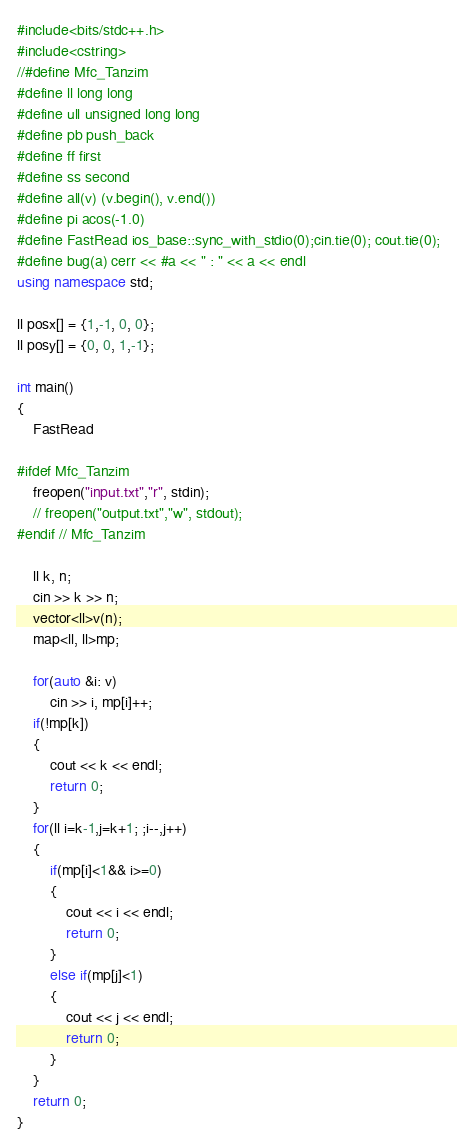<code> <loc_0><loc_0><loc_500><loc_500><_C++_>#include<bits/stdc++.h>
#include<cstring>
//#define Mfc_Tanzim
#define ll long long
#define ull unsigned long long
#define pb push_back
#define ff first
#define ss second
#define all(v) (v.begin(), v.end())
#define pi acos(-1.0)
#define FastRead ios_base::sync_with_stdio(0);cin.tie(0); cout.tie(0);
#define bug(a) cerr << #a << " : " << a << endl
using namespace std;

ll posx[] = {1,-1, 0, 0};
ll posy[] = {0, 0, 1,-1};

int main()
{
    FastRead

#ifdef Mfc_Tanzim
    freopen("input.txt","r", stdin);
    // freopen("output.txt","w", stdout);
#endif // Mfc_Tanzim

    ll k, n;
    cin >> k >> n;
    vector<ll>v(n);
    map<ll, ll>mp;

    for(auto &i: v)
        cin >> i, mp[i]++;
    if(!mp[k])
    {
        cout << k << endl;
        return 0;
    }
    for(ll i=k-1,j=k+1; ;i--,j++)
    {
        if(mp[i]<1&& i>=0)
        {
            cout << i << endl;
            return 0;
        }
        else if(mp[j]<1)
        {
            cout << j << endl;
            return 0;
        }
    }
    return 0;
}
</code> 